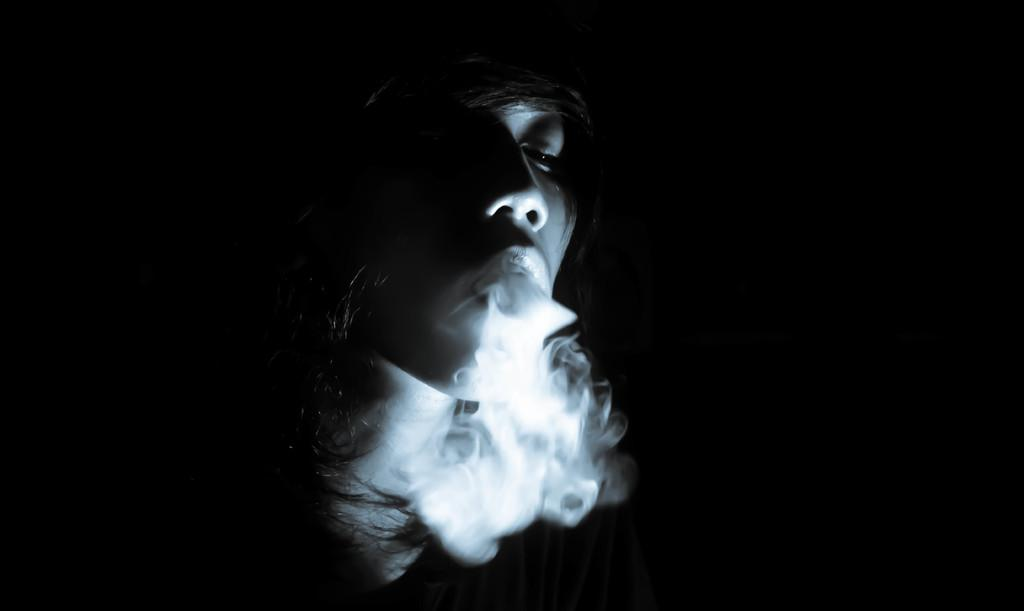What is the main subject of the image? There is a person in the image. What is the person doing in the image? Smoke is coming from the person's mouth. Can you describe the background of the image? The background of the image is dark. What type of tools does the carpenter have in the image? There is no carpenter present in the image, nor are there any tools visible. What country is depicted in the image? The image does not depict any specific country. 